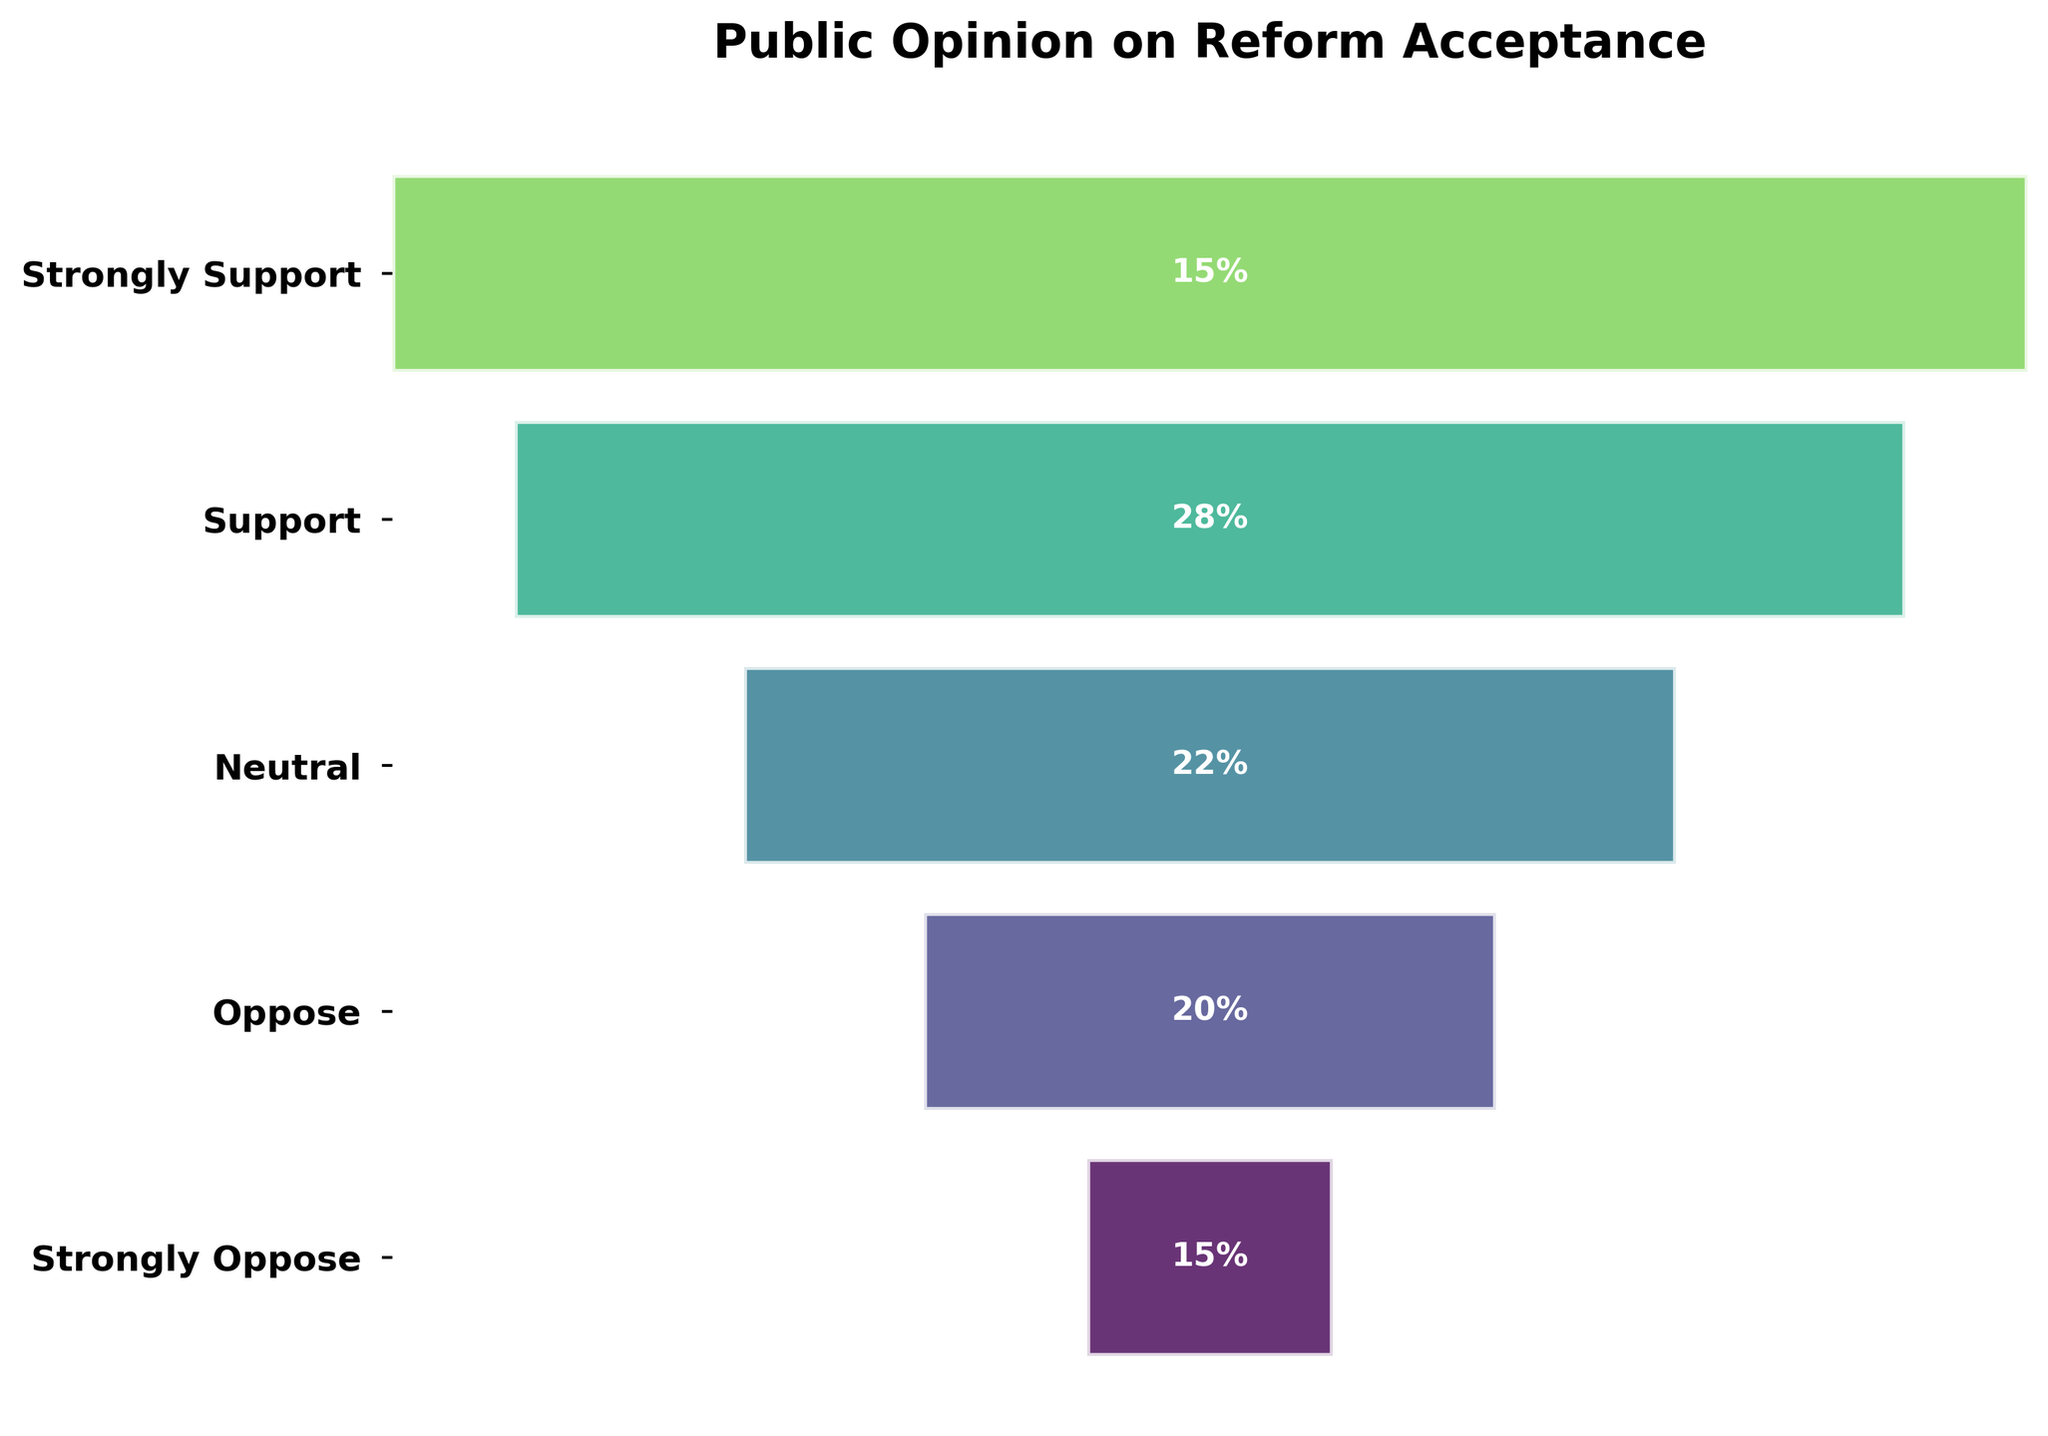What is the title of the figure? The title is usually placed at the top of the figure and provides a summary of what the chart represents. In this case, it indicates what the survey is about.
Answer: Public Opinion on Reform Acceptance Which category has the highest percentage? Check the percentages listed inside the bars and identify the largest value. In this case, "Support" has the highest percentage.
Answer: Support What are the percentages for 'Neutral' and 'Oppose'? Look for the segments labeled "Neutral" and "Oppose" and record the percentages shown within those segments.
Answer: 22% and 20% What is the sum of the percentages for 'Strongly Support' and 'Strongly Oppose'? Find the percentages associated with "Strongly Support" and "Strongly Oppose" and add them together: 15% + 15%.
Answer: 30% Which has a larger percentage: 'Neutral' or 'Oppose'? Compare the values of the bars labeled "Neutral" and "Oppose." Here, "Neutral" has 22%, and "Oppose" has 20%.
Answer: Neutral Which categories have equal percentages? Look for categories with the same percentage values by comparing the numbers inside the bars. In this case, "Strongly Support" and "Strongly Oppose" both have 15%.
Answer: Strongly Support and Strongly Oppose What is the cumulative percentage for the categories 'Support' and above? Add the percentages from the top of the funnel to the "Support" category. This includes "Strongly Support" and "Support": 15% + 28% = 43%.
Answer: 43% How many categories are there in total? Count the number of distinct bars in the funnel chart. There are five categories.
Answer: 5 Is the percentage of 'Neutral' greater than 20%? Check the percentage value in the "Neutral" segment. It shows 22%, which is indeed greater than 20%.
Answer: Yes What portion of the total is represented by 'Support' compared to 'Neutral' and 'Oppose' combined? Calculate the combined percentage of "Neutral" and "Oppose": 22% + 20% = 42%. Then compare "Support" (28%) to this value.
Answer: Less 